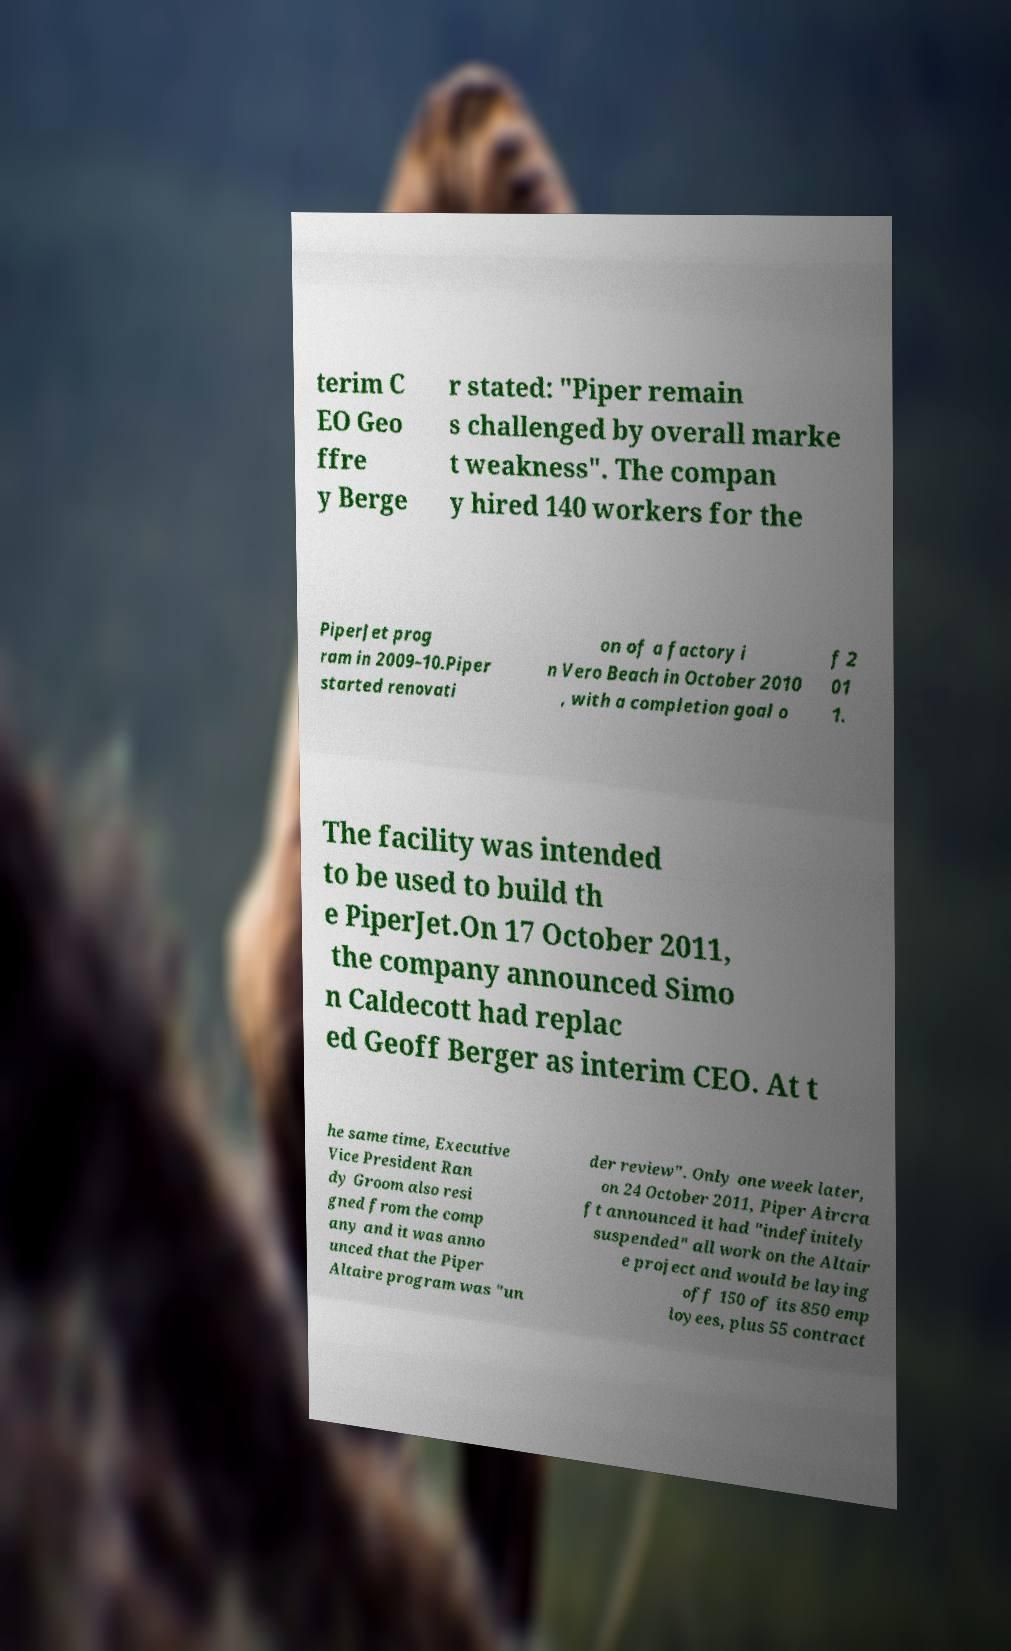What messages or text are displayed in this image? I need them in a readable, typed format. terim C EO Geo ffre y Berge r stated: "Piper remain s challenged by overall marke t weakness". The compan y hired 140 workers for the PiperJet prog ram in 2009–10.Piper started renovati on of a factory i n Vero Beach in October 2010 , with a completion goal o f 2 01 1. The facility was intended to be used to build th e PiperJet.On 17 October 2011, the company announced Simo n Caldecott had replac ed Geoff Berger as interim CEO. At t he same time, Executive Vice President Ran dy Groom also resi gned from the comp any and it was anno unced that the Piper Altaire program was "un der review". Only one week later, on 24 October 2011, Piper Aircra ft announced it had "indefinitely suspended" all work on the Altair e project and would be laying off 150 of its 850 emp loyees, plus 55 contract 